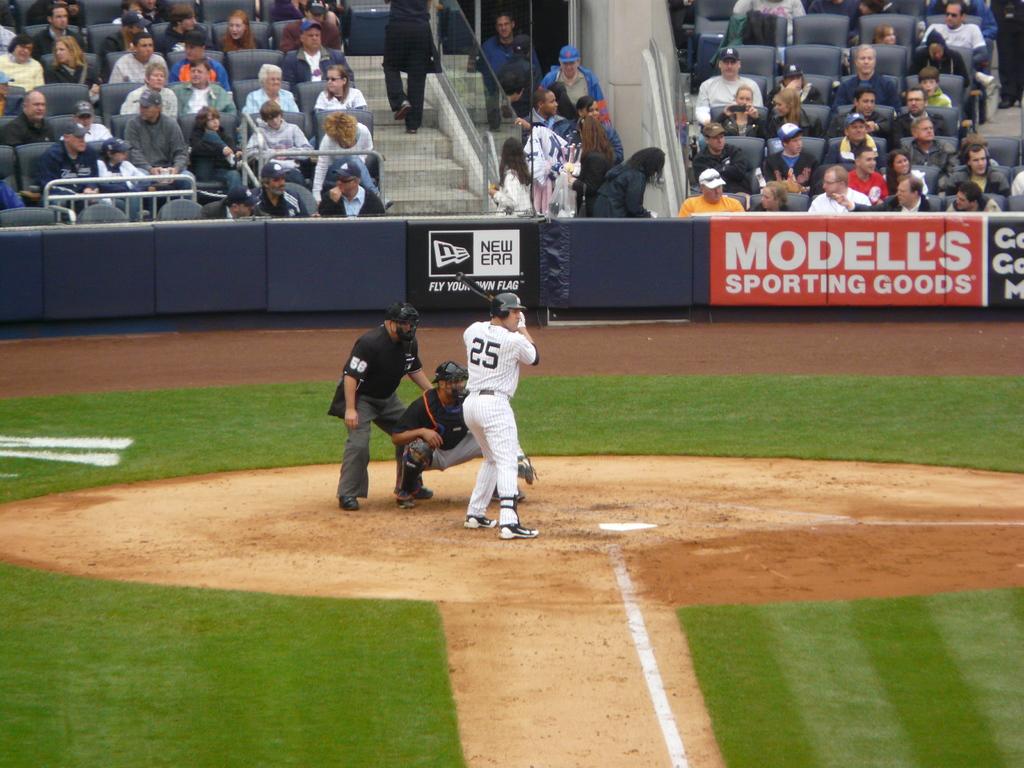What sporting goods team is on the banner?
Ensure brevity in your answer.  Modell's. What is written on the add directly behind the batter?
Ensure brevity in your answer.  New era. 